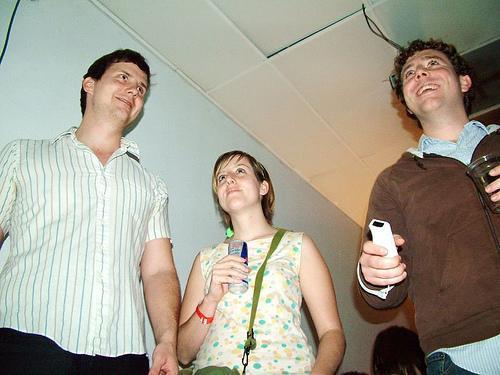How many people are there?
Give a very brief answer. 4. How many people have wristbands on their arms?
Give a very brief answer. 2. How many people are visible?
Give a very brief answer. 4. 